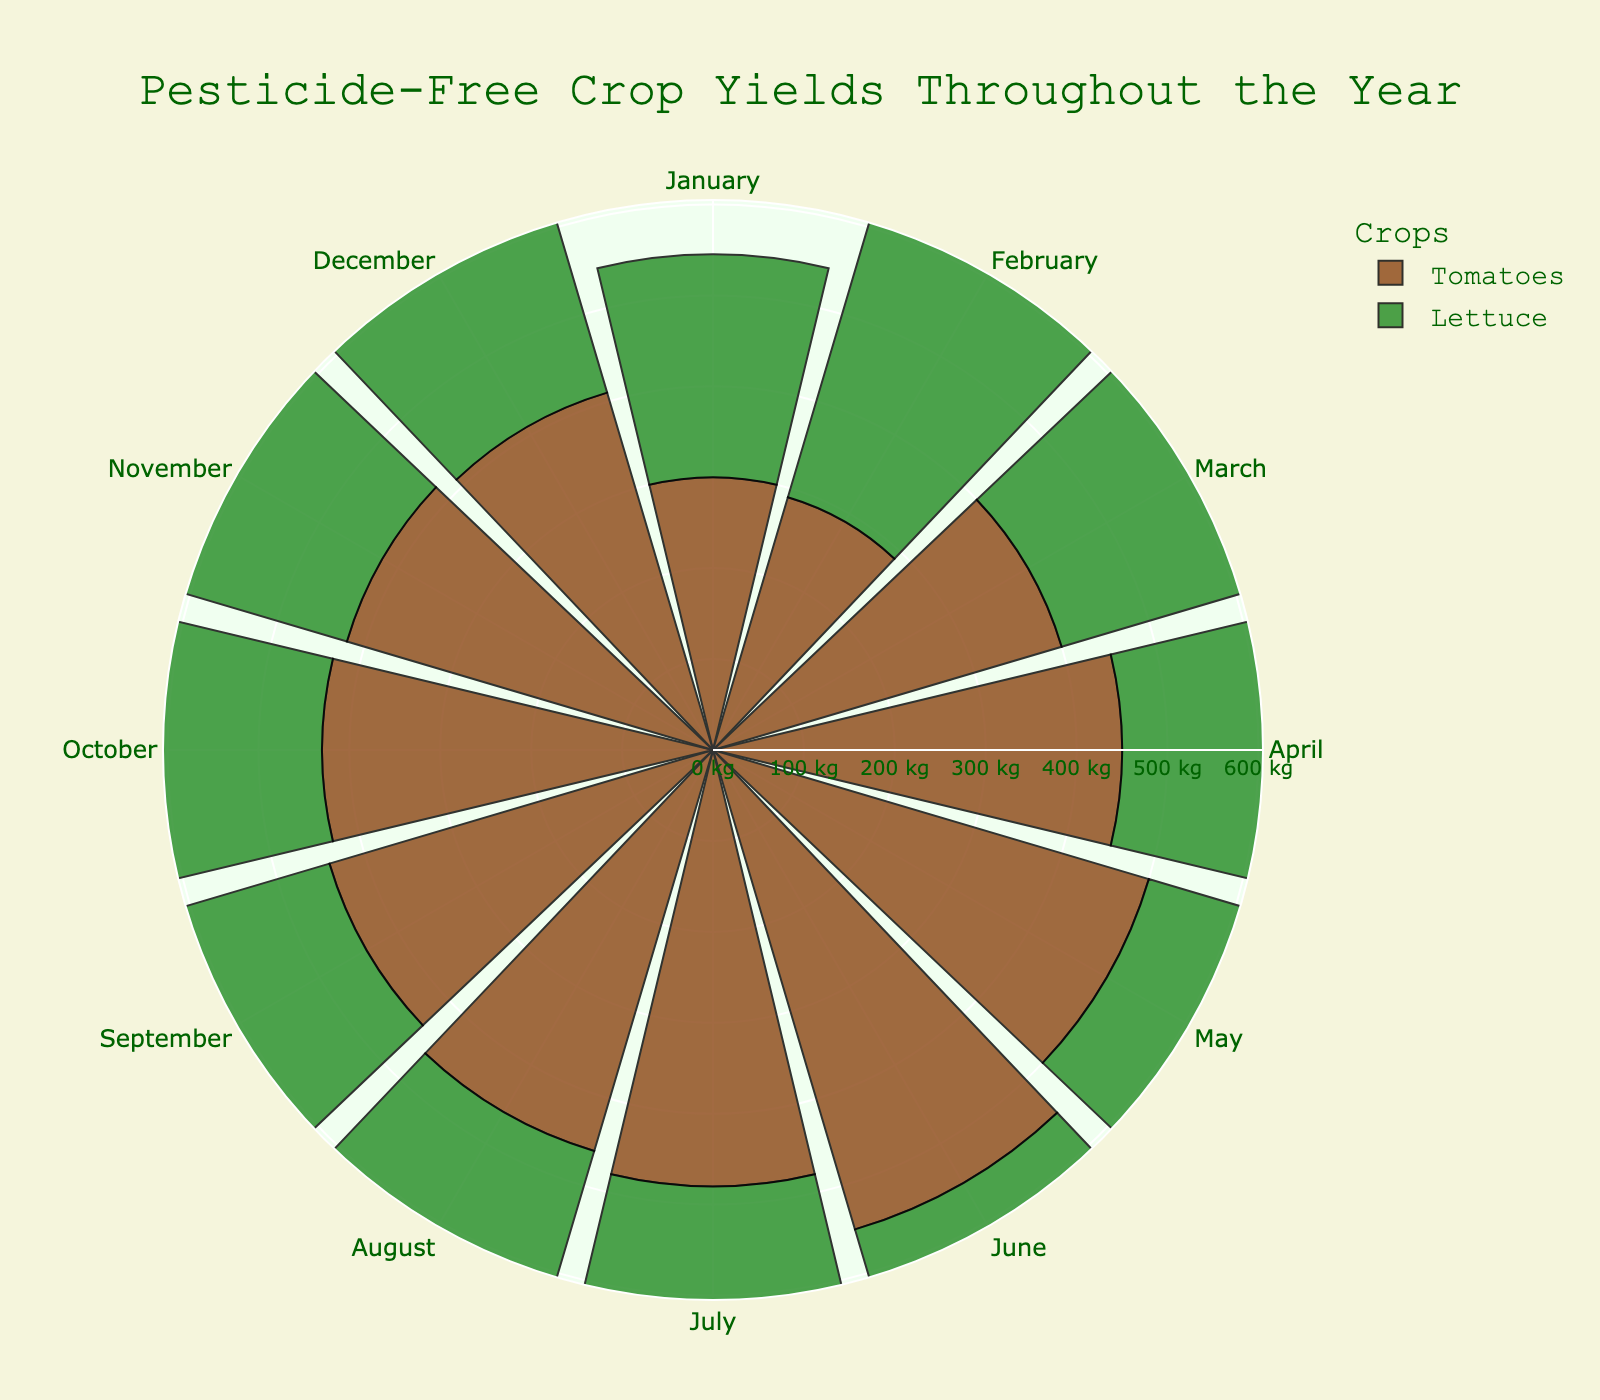What is the title of the rose chart? The title is located at the top of the chart and provides a summary of what the chart depicts. The title reads, "Pesticide-Free Crop Yields Throughout the Year".
Answer: Pesticide-Free Crop Yields Throughout the Year How many distinct crops are represented in the rose chart? The rose chart has different colored radial axes for distinct crops. Each crop is listed in the legend. The two crops represented are Tomatoes and Lettuce.
Answer: 2 During which month does the yield of Lettuce peak? By looking at the length of the green bars corresponding to Lettuce, the longest bar appears in June.
Answer: June In which months are the yields of Tomatoes and Lettuce equal or closest? Observing the lengths of the brown bars for Tomatoes and green bars for Lettuce, yields are closest in January and December, though not equal.
Answer: January, December What is the color used to represent Tomatoes? Each crop has a distinct color in the chart. Tomatoes are represented by the brown color as seen in the legend and the radial bars.
Answer: Brown What is the average monthly yield of Tomatoes for the second quarter of the year? (April, May, June) To find the average yield of Tomatoes for the second quarter (April, May, June), add the yields for these months together and divide by 3. The yields are 450, 500, and 550 respectively. Average = (450 + 500 + 550) / 3 = 1500 / 3 = 500.
Answer: 500 Which crop has a more stable yield throughout the year? Stability can be assessed by looking at the variability in the lengths of the bars for each crop. Lettuce has less variability in bar lengths compared to Tomatoes, which fluctuate more.
Answer: Lettuce What is the difference in yield for Tomatoes between the highest and lowest months? The highest yield for Tomatoes is in June (550) and the lowest is in February (290). The difference is 550 - 290 = 260.
Answer: 260 What is the combined yield of both crops in March? The yields for March are Tomatoes (400) and Lettuce (360). The combined yield is 400 + 360 = 760.
Answer: 760 In which month does the yield of Tomatoes decrease significantly compared to the previous month? Observing the lengths of the brown bars, a significant drop is noted from June (550) to July (480).
Answer: July 